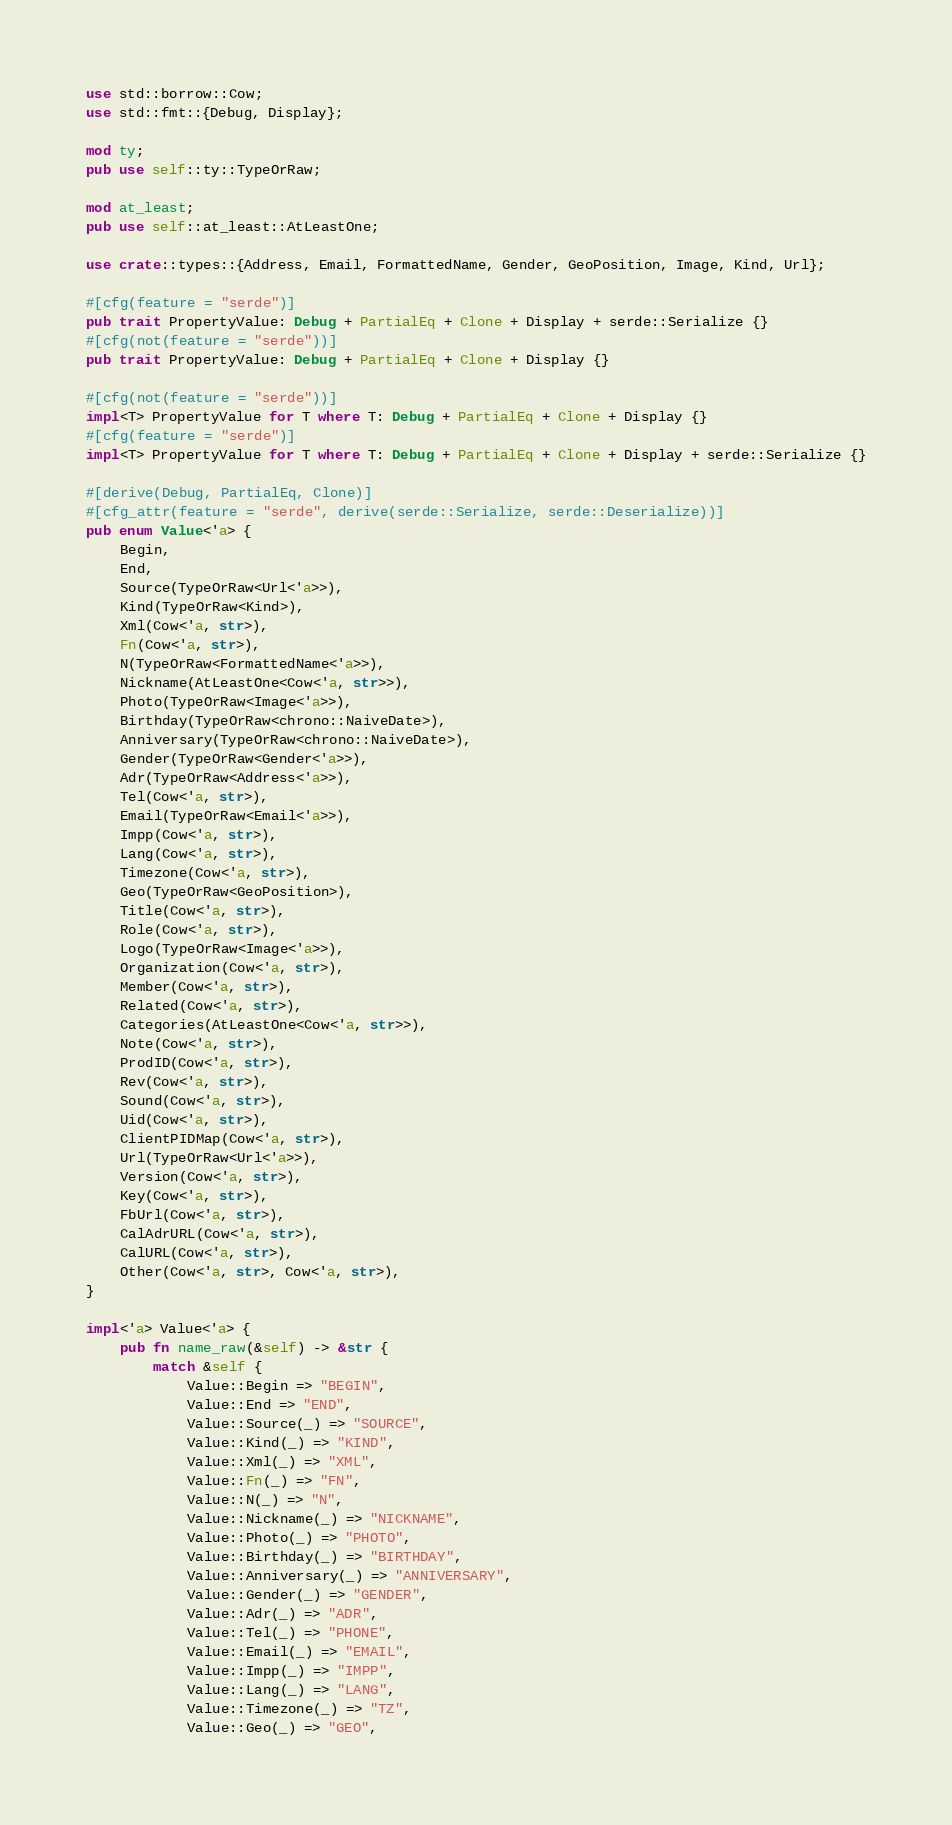Convert code to text. <code><loc_0><loc_0><loc_500><loc_500><_Rust_>use std::borrow::Cow;
use std::fmt::{Debug, Display};

mod ty;
pub use self::ty::TypeOrRaw;

mod at_least;
pub use self::at_least::AtLeastOne;

use crate::types::{Address, Email, FormattedName, Gender, GeoPosition, Image, Kind, Url};

#[cfg(feature = "serde")]
pub trait PropertyValue: Debug + PartialEq + Clone + Display + serde::Serialize {}
#[cfg(not(feature = "serde"))]
pub trait PropertyValue: Debug + PartialEq + Clone + Display {}

#[cfg(not(feature = "serde"))]
impl<T> PropertyValue for T where T: Debug + PartialEq + Clone + Display {}
#[cfg(feature = "serde")]
impl<T> PropertyValue for T where T: Debug + PartialEq + Clone + Display + serde::Serialize {}

#[derive(Debug, PartialEq, Clone)]
#[cfg_attr(feature = "serde", derive(serde::Serialize, serde::Deserialize))]
pub enum Value<'a> {
    Begin,
    End,
    Source(TypeOrRaw<Url<'a>>),
    Kind(TypeOrRaw<Kind>),
    Xml(Cow<'a, str>),
    Fn(Cow<'a, str>),
    N(TypeOrRaw<FormattedName<'a>>),
    Nickname(AtLeastOne<Cow<'a, str>>),
    Photo(TypeOrRaw<Image<'a>>),
    Birthday(TypeOrRaw<chrono::NaiveDate>),
    Anniversary(TypeOrRaw<chrono::NaiveDate>),
    Gender(TypeOrRaw<Gender<'a>>),
    Adr(TypeOrRaw<Address<'a>>),
    Tel(Cow<'a, str>),
    Email(TypeOrRaw<Email<'a>>),
    Impp(Cow<'a, str>),
    Lang(Cow<'a, str>),
    Timezone(Cow<'a, str>),
    Geo(TypeOrRaw<GeoPosition>),
    Title(Cow<'a, str>),
    Role(Cow<'a, str>),
    Logo(TypeOrRaw<Image<'a>>),
    Organization(Cow<'a, str>),
    Member(Cow<'a, str>),
    Related(Cow<'a, str>),
    Categories(AtLeastOne<Cow<'a, str>>),
    Note(Cow<'a, str>),
    ProdID(Cow<'a, str>),
    Rev(Cow<'a, str>),
    Sound(Cow<'a, str>),
    Uid(Cow<'a, str>),
    ClientPIDMap(Cow<'a, str>),
    Url(TypeOrRaw<Url<'a>>),
    Version(Cow<'a, str>),
    Key(Cow<'a, str>),
    FbUrl(Cow<'a, str>),
    CalAdrURL(Cow<'a, str>),
    CalURL(Cow<'a, str>),
    Other(Cow<'a, str>, Cow<'a, str>),
}

impl<'a> Value<'a> {
    pub fn name_raw(&self) -> &str {
        match &self {
            Value::Begin => "BEGIN",
            Value::End => "END",
            Value::Source(_) => "SOURCE",
            Value::Kind(_) => "KIND",
            Value::Xml(_) => "XML",
            Value::Fn(_) => "FN",
            Value::N(_) => "N",
            Value::Nickname(_) => "NICKNAME",
            Value::Photo(_) => "PHOTO",
            Value::Birthday(_) => "BIRTHDAY",
            Value::Anniversary(_) => "ANNIVERSARY",
            Value::Gender(_) => "GENDER",
            Value::Adr(_) => "ADR",
            Value::Tel(_) => "PHONE",
            Value::Email(_) => "EMAIL",
            Value::Impp(_) => "IMPP",
            Value::Lang(_) => "LANG",
            Value::Timezone(_) => "TZ",
            Value::Geo(_) => "GEO",</code> 